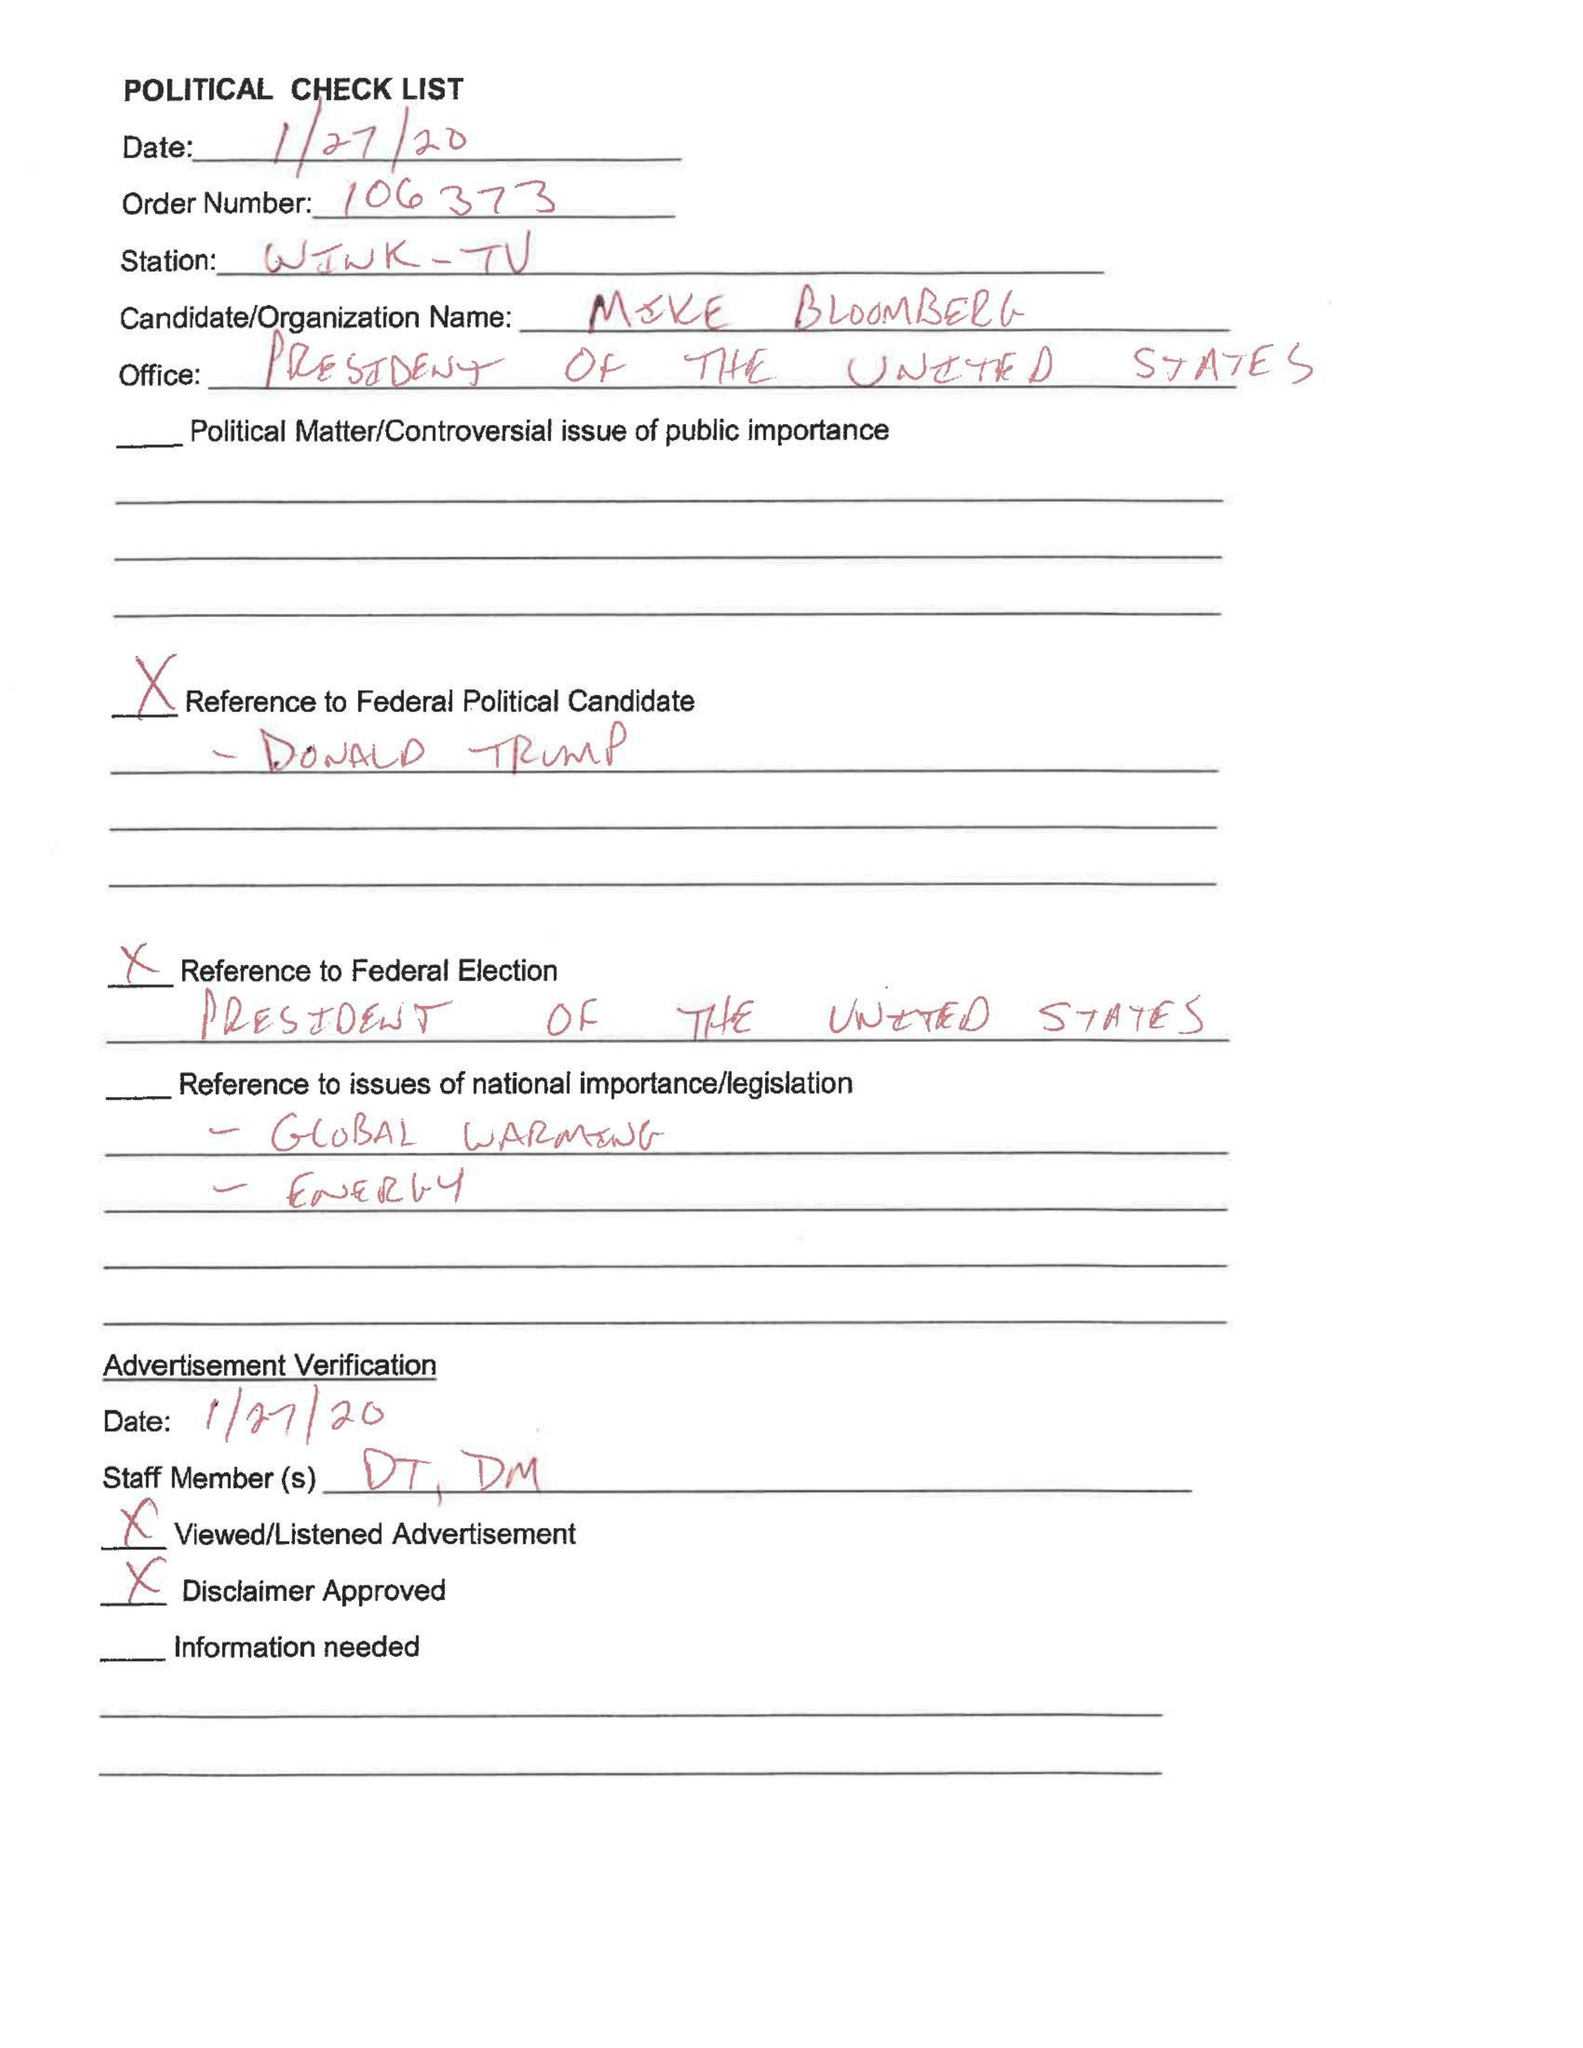What is the value for the flight_from?
Answer the question using a single word or phrase. None 